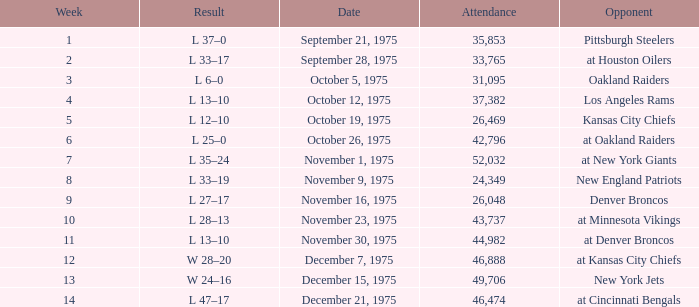What is the highest Week when the opponent was the los angeles rams, with more than 37,382 in Attendance? None. 